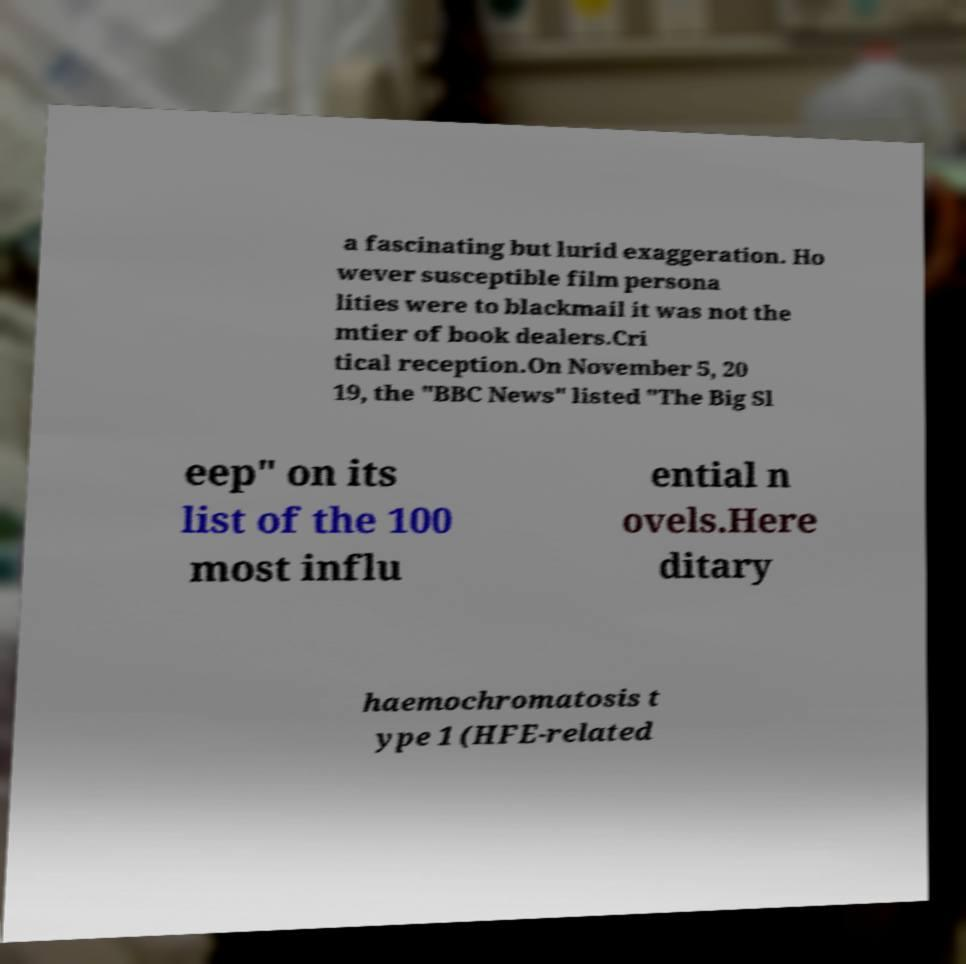Can you read and provide the text displayed in the image?This photo seems to have some interesting text. Can you extract and type it out for me? a fascinating but lurid exaggeration. Ho wever susceptible film persona lities were to blackmail it was not the mtier of book dealers.Cri tical reception.On November 5, 20 19, the "BBC News" listed "The Big Sl eep" on its list of the 100 most influ ential n ovels.Here ditary haemochromatosis t ype 1 (HFE-related 